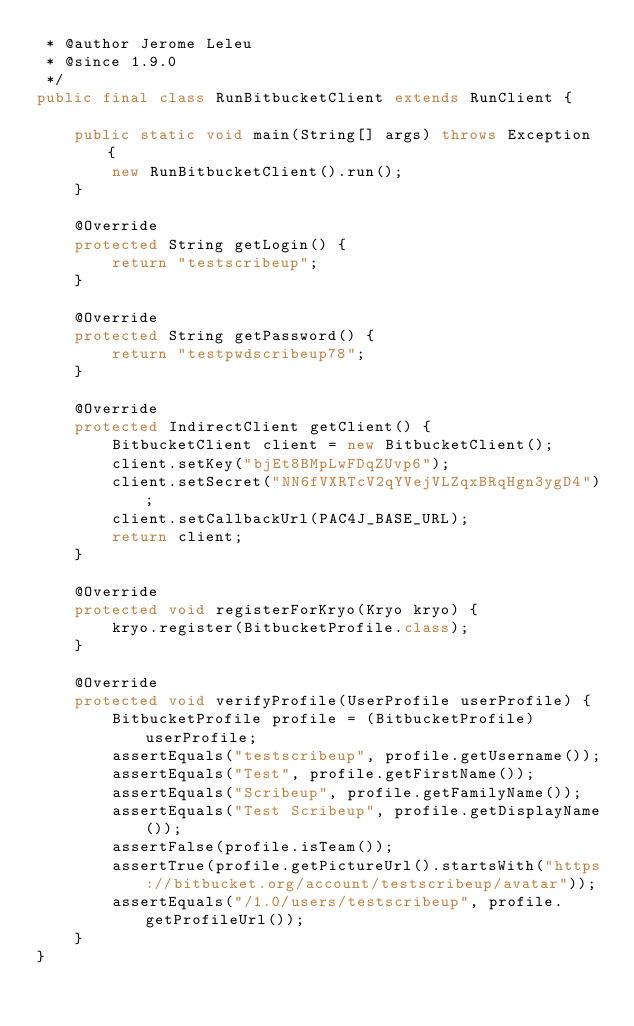<code> <loc_0><loc_0><loc_500><loc_500><_Java_> * @author Jerome Leleu
 * @since 1.9.0
 */
public final class RunBitbucketClient extends RunClient {

    public static void main(String[] args) throws Exception {
        new RunBitbucketClient().run();
    }

    @Override
    protected String getLogin() {
        return "testscribeup";
    }

    @Override
    protected String getPassword() {
        return "testpwdscribeup78";
    }

    @Override
    protected IndirectClient getClient() {
        BitbucketClient client = new BitbucketClient();
        client.setKey("bjEt8BMpLwFDqZUvp6");
        client.setSecret("NN6fVXRTcV2qYVejVLZqxBRqHgn3ygD4");
        client.setCallbackUrl(PAC4J_BASE_URL);
        return client;
    }

    @Override
    protected void registerForKryo(Kryo kryo) {
        kryo.register(BitbucketProfile.class);
    }

    @Override
    protected void verifyProfile(UserProfile userProfile) {
        BitbucketProfile profile = (BitbucketProfile) userProfile;
        assertEquals("testscribeup", profile.getUsername());
        assertEquals("Test", profile.getFirstName());
        assertEquals("Scribeup", profile.getFamilyName());
        assertEquals("Test Scribeup", profile.getDisplayName());
        assertFalse(profile.isTeam());
        assertTrue(profile.getPictureUrl().startsWith("https://bitbucket.org/account/testscribeup/avatar"));
        assertEquals("/1.0/users/testscribeup", profile.getProfileUrl());
    }
}
</code> 